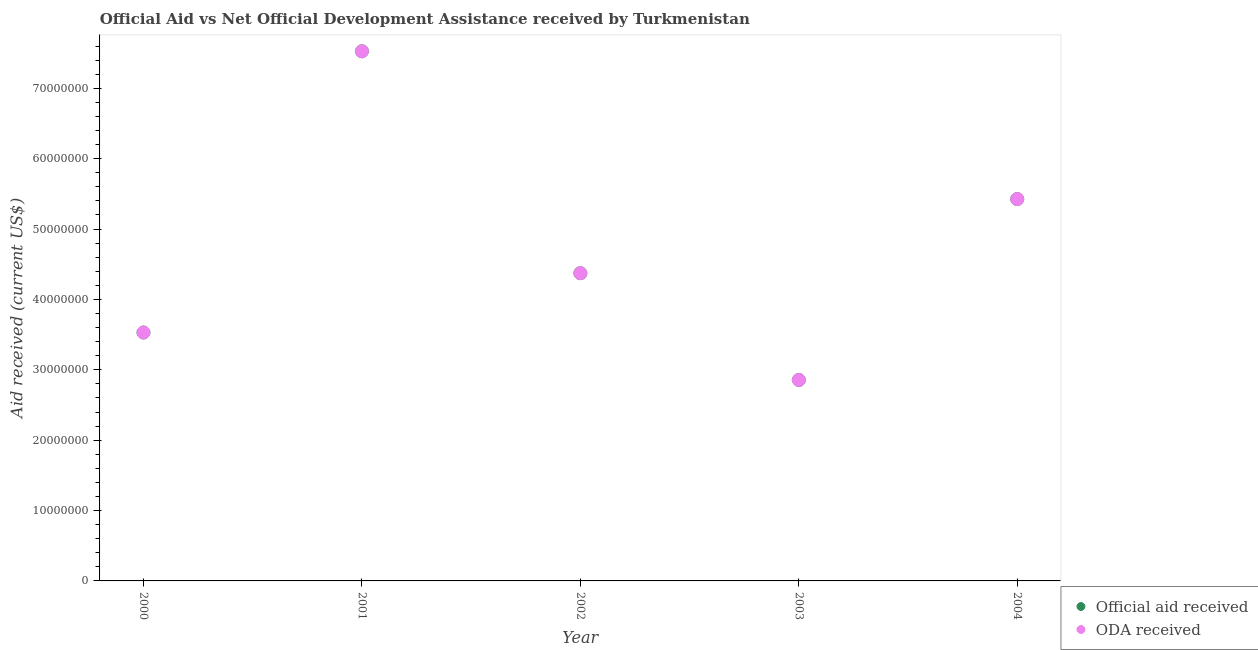What is the official aid received in 2002?
Provide a short and direct response. 4.37e+07. Across all years, what is the maximum official aid received?
Ensure brevity in your answer.  7.53e+07. Across all years, what is the minimum official aid received?
Offer a very short reply. 2.86e+07. In which year was the oda received maximum?
Offer a terse response. 2001. In which year was the official aid received minimum?
Ensure brevity in your answer.  2003. What is the total oda received in the graph?
Make the answer very short. 2.37e+08. What is the difference between the official aid received in 2000 and that in 2003?
Your answer should be very brief. 6.74e+06. What is the difference between the oda received in 2003 and the official aid received in 2001?
Your answer should be very brief. -4.67e+07. What is the average official aid received per year?
Make the answer very short. 4.74e+07. In the year 2004, what is the difference between the oda received and official aid received?
Give a very brief answer. 0. What is the ratio of the official aid received in 2003 to that in 2004?
Keep it short and to the point. 0.53. What is the difference between the highest and the second highest oda received?
Make the answer very short. 2.10e+07. What is the difference between the highest and the lowest official aid received?
Your response must be concise. 4.67e+07. Is the sum of the oda received in 2003 and 2004 greater than the maximum official aid received across all years?
Offer a very short reply. Yes. Are the values on the major ticks of Y-axis written in scientific E-notation?
Your answer should be very brief. No. Does the graph contain grids?
Keep it short and to the point. No. How are the legend labels stacked?
Your answer should be very brief. Vertical. What is the title of the graph?
Make the answer very short. Official Aid vs Net Official Development Assistance received by Turkmenistan . Does "Diarrhea" appear as one of the legend labels in the graph?
Your answer should be compact. No. What is the label or title of the Y-axis?
Your answer should be compact. Aid received (current US$). What is the Aid received (current US$) in Official aid received in 2000?
Ensure brevity in your answer.  3.53e+07. What is the Aid received (current US$) in ODA received in 2000?
Make the answer very short. 3.53e+07. What is the Aid received (current US$) of Official aid received in 2001?
Ensure brevity in your answer.  7.53e+07. What is the Aid received (current US$) in ODA received in 2001?
Give a very brief answer. 7.53e+07. What is the Aid received (current US$) in Official aid received in 2002?
Your answer should be very brief. 4.37e+07. What is the Aid received (current US$) in ODA received in 2002?
Give a very brief answer. 4.37e+07. What is the Aid received (current US$) of Official aid received in 2003?
Your answer should be very brief. 2.86e+07. What is the Aid received (current US$) of ODA received in 2003?
Ensure brevity in your answer.  2.86e+07. What is the Aid received (current US$) in Official aid received in 2004?
Ensure brevity in your answer.  5.43e+07. What is the Aid received (current US$) in ODA received in 2004?
Provide a short and direct response. 5.43e+07. Across all years, what is the maximum Aid received (current US$) of Official aid received?
Offer a very short reply. 7.53e+07. Across all years, what is the maximum Aid received (current US$) of ODA received?
Provide a short and direct response. 7.53e+07. Across all years, what is the minimum Aid received (current US$) of Official aid received?
Ensure brevity in your answer.  2.86e+07. Across all years, what is the minimum Aid received (current US$) in ODA received?
Your answer should be compact. 2.86e+07. What is the total Aid received (current US$) in Official aid received in the graph?
Your answer should be very brief. 2.37e+08. What is the total Aid received (current US$) in ODA received in the graph?
Provide a short and direct response. 2.37e+08. What is the difference between the Aid received (current US$) in Official aid received in 2000 and that in 2001?
Your response must be concise. -4.00e+07. What is the difference between the Aid received (current US$) of ODA received in 2000 and that in 2001?
Offer a very short reply. -4.00e+07. What is the difference between the Aid received (current US$) of Official aid received in 2000 and that in 2002?
Your response must be concise. -8.43e+06. What is the difference between the Aid received (current US$) in ODA received in 2000 and that in 2002?
Make the answer very short. -8.43e+06. What is the difference between the Aid received (current US$) in Official aid received in 2000 and that in 2003?
Offer a very short reply. 6.74e+06. What is the difference between the Aid received (current US$) in ODA received in 2000 and that in 2003?
Provide a short and direct response. 6.74e+06. What is the difference between the Aid received (current US$) in Official aid received in 2000 and that in 2004?
Provide a succinct answer. -1.90e+07. What is the difference between the Aid received (current US$) in ODA received in 2000 and that in 2004?
Keep it short and to the point. -1.90e+07. What is the difference between the Aid received (current US$) in Official aid received in 2001 and that in 2002?
Keep it short and to the point. 3.15e+07. What is the difference between the Aid received (current US$) in ODA received in 2001 and that in 2002?
Ensure brevity in your answer.  3.15e+07. What is the difference between the Aid received (current US$) of Official aid received in 2001 and that in 2003?
Your answer should be very brief. 4.67e+07. What is the difference between the Aid received (current US$) in ODA received in 2001 and that in 2003?
Offer a very short reply. 4.67e+07. What is the difference between the Aid received (current US$) in Official aid received in 2001 and that in 2004?
Provide a succinct answer. 2.10e+07. What is the difference between the Aid received (current US$) in ODA received in 2001 and that in 2004?
Your response must be concise. 2.10e+07. What is the difference between the Aid received (current US$) of Official aid received in 2002 and that in 2003?
Ensure brevity in your answer.  1.52e+07. What is the difference between the Aid received (current US$) in ODA received in 2002 and that in 2003?
Provide a succinct answer. 1.52e+07. What is the difference between the Aid received (current US$) of Official aid received in 2002 and that in 2004?
Your response must be concise. -1.05e+07. What is the difference between the Aid received (current US$) of ODA received in 2002 and that in 2004?
Offer a very short reply. -1.05e+07. What is the difference between the Aid received (current US$) in Official aid received in 2003 and that in 2004?
Your answer should be compact. -2.57e+07. What is the difference between the Aid received (current US$) in ODA received in 2003 and that in 2004?
Your answer should be compact. -2.57e+07. What is the difference between the Aid received (current US$) of Official aid received in 2000 and the Aid received (current US$) of ODA received in 2001?
Provide a succinct answer. -4.00e+07. What is the difference between the Aid received (current US$) in Official aid received in 2000 and the Aid received (current US$) in ODA received in 2002?
Keep it short and to the point. -8.43e+06. What is the difference between the Aid received (current US$) of Official aid received in 2000 and the Aid received (current US$) of ODA received in 2003?
Provide a succinct answer. 6.74e+06. What is the difference between the Aid received (current US$) of Official aid received in 2000 and the Aid received (current US$) of ODA received in 2004?
Offer a very short reply. -1.90e+07. What is the difference between the Aid received (current US$) in Official aid received in 2001 and the Aid received (current US$) in ODA received in 2002?
Provide a short and direct response. 3.15e+07. What is the difference between the Aid received (current US$) of Official aid received in 2001 and the Aid received (current US$) of ODA received in 2003?
Provide a succinct answer. 4.67e+07. What is the difference between the Aid received (current US$) of Official aid received in 2001 and the Aid received (current US$) of ODA received in 2004?
Offer a terse response. 2.10e+07. What is the difference between the Aid received (current US$) of Official aid received in 2002 and the Aid received (current US$) of ODA received in 2003?
Ensure brevity in your answer.  1.52e+07. What is the difference between the Aid received (current US$) of Official aid received in 2002 and the Aid received (current US$) of ODA received in 2004?
Make the answer very short. -1.05e+07. What is the difference between the Aid received (current US$) of Official aid received in 2003 and the Aid received (current US$) of ODA received in 2004?
Keep it short and to the point. -2.57e+07. What is the average Aid received (current US$) in Official aid received per year?
Your answer should be compact. 4.74e+07. What is the average Aid received (current US$) in ODA received per year?
Your answer should be compact. 4.74e+07. In the year 2000, what is the difference between the Aid received (current US$) in Official aid received and Aid received (current US$) in ODA received?
Make the answer very short. 0. In the year 2001, what is the difference between the Aid received (current US$) in Official aid received and Aid received (current US$) in ODA received?
Offer a terse response. 0. In the year 2002, what is the difference between the Aid received (current US$) of Official aid received and Aid received (current US$) of ODA received?
Your answer should be very brief. 0. In the year 2003, what is the difference between the Aid received (current US$) of Official aid received and Aid received (current US$) of ODA received?
Offer a very short reply. 0. In the year 2004, what is the difference between the Aid received (current US$) of Official aid received and Aid received (current US$) of ODA received?
Your response must be concise. 0. What is the ratio of the Aid received (current US$) in Official aid received in 2000 to that in 2001?
Your response must be concise. 0.47. What is the ratio of the Aid received (current US$) in ODA received in 2000 to that in 2001?
Your answer should be compact. 0.47. What is the ratio of the Aid received (current US$) in Official aid received in 2000 to that in 2002?
Offer a very short reply. 0.81. What is the ratio of the Aid received (current US$) of ODA received in 2000 to that in 2002?
Offer a very short reply. 0.81. What is the ratio of the Aid received (current US$) of Official aid received in 2000 to that in 2003?
Offer a very short reply. 1.24. What is the ratio of the Aid received (current US$) of ODA received in 2000 to that in 2003?
Your answer should be very brief. 1.24. What is the ratio of the Aid received (current US$) in Official aid received in 2000 to that in 2004?
Offer a terse response. 0.65. What is the ratio of the Aid received (current US$) in ODA received in 2000 to that in 2004?
Provide a short and direct response. 0.65. What is the ratio of the Aid received (current US$) of Official aid received in 2001 to that in 2002?
Keep it short and to the point. 1.72. What is the ratio of the Aid received (current US$) of ODA received in 2001 to that in 2002?
Provide a short and direct response. 1.72. What is the ratio of the Aid received (current US$) in Official aid received in 2001 to that in 2003?
Your answer should be very brief. 2.64. What is the ratio of the Aid received (current US$) of ODA received in 2001 to that in 2003?
Offer a very short reply. 2.64. What is the ratio of the Aid received (current US$) in Official aid received in 2001 to that in 2004?
Give a very brief answer. 1.39. What is the ratio of the Aid received (current US$) in ODA received in 2001 to that in 2004?
Offer a terse response. 1.39. What is the ratio of the Aid received (current US$) of Official aid received in 2002 to that in 2003?
Your answer should be compact. 1.53. What is the ratio of the Aid received (current US$) of ODA received in 2002 to that in 2003?
Provide a short and direct response. 1.53. What is the ratio of the Aid received (current US$) in Official aid received in 2002 to that in 2004?
Keep it short and to the point. 0.81. What is the ratio of the Aid received (current US$) of ODA received in 2002 to that in 2004?
Provide a succinct answer. 0.81. What is the ratio of the Aid received (current US$) in Official aid received in 2003 to that in 2004?
Give a very brief answer. 0.53. What is the ratio of the Aid received (current US$) of ODA received in 2003 to that in 2004?
Ensure brevity in your answer.  0.53. What is the difference between the highest and the second highest Aid received (current US$) in Official aid received?
Make the answer very short. 2.10e+07. What is the difference between the highest and the second highest Aid received (current US$) in ODA received?
Ensure brevity in your answer.  2.10e+07. What is the difference between the highest and the lowest Aid received (current US$) in Official aid received?
Your answer should be compact. 4.67e+07. What is the difference between the highest and the lowest Aid received (current US$) in ODA received?
Your response must be concise. 4.67e+07. 